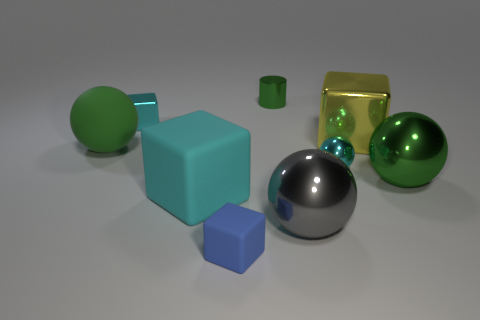Subtract all cyan metal spheres. How many spheres are left? 3 Subtract 2 spheres. How many spheres are left? 2 Add 1 tiny brown matte spheres. How many objects exist? 10 Add 1 green rubber objects. How many green rubber objects are left? 2 Add 9 tiny red metallic cylinders. How many tiny red metallic cylinders exist? 9 Subtract all yellow blocks. How many blocks are left? 3 Subtract 0 blue balls. How many objects are left? 9 Subtract all cylinders. How many objects are left? 8 Subtract all purple spheres. Subtract all cyan cylinders. How many spheres are left? 4 Subtract all red cylinders. How many cyan spheres are left? 1 